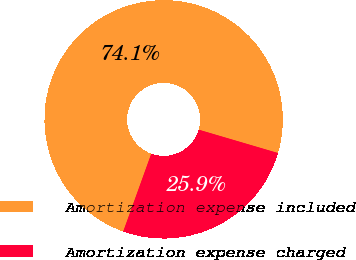Convert chart. <chart><loc_0><loc_0><loc_500><loc_500><pie_chart><fcel>Amortization expense included<fcel>Amortization expense charged<nl><fcel>74.05%<fcel>25.95%<nl></chart> 